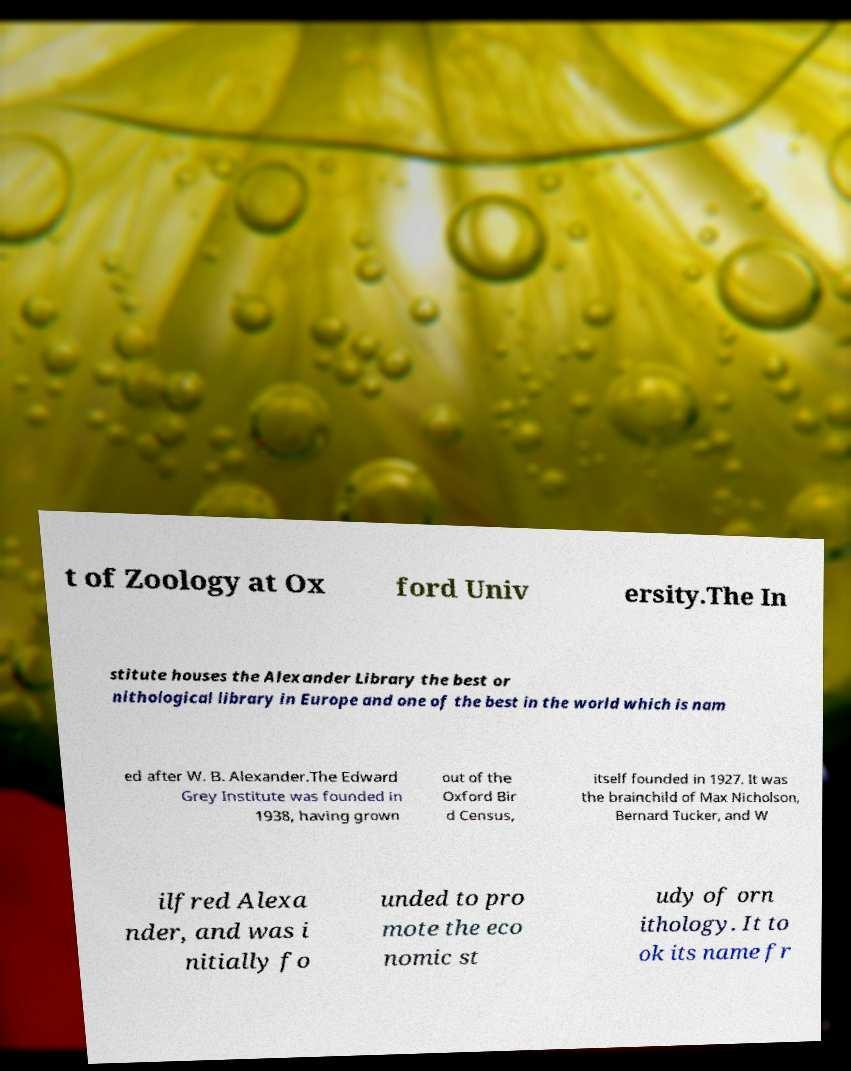For documentation purposes, I need the text within this image transcribed. Could you provide that? t of Zoology at Ox ford Univ ersity.The In stitute houses the Alexander Library the best or nithological library in Europe and one of the best in the world which is nam ed after W. B. Alexander.The Edward Grey Institute was founded in 1938, having grown out of the Oxford Bir d Census, itself founded in 1927. It was the brainchild of Max Nicholson, Bernard Tucker, and W ilfred Alexa nder, and was i nitially fo unded to pro mote the eco nomic st udy of orn ithology. It to ok its name fr 